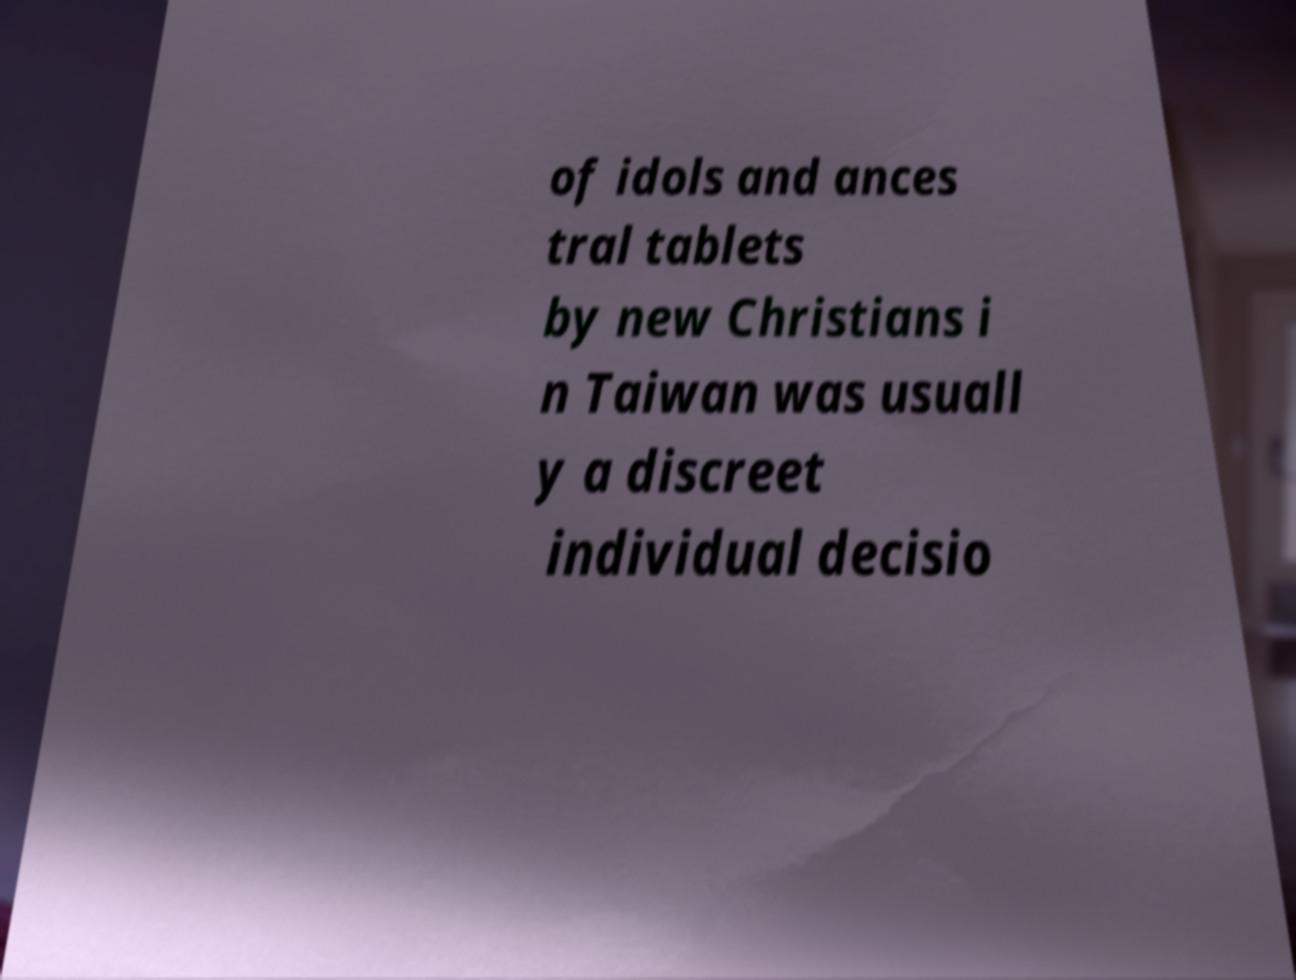I need the written content from this picture converted into text. Can you do that? of idols and ances tral tablets by new Christians i n Taiwan was usuall y a discreet individual decisio 